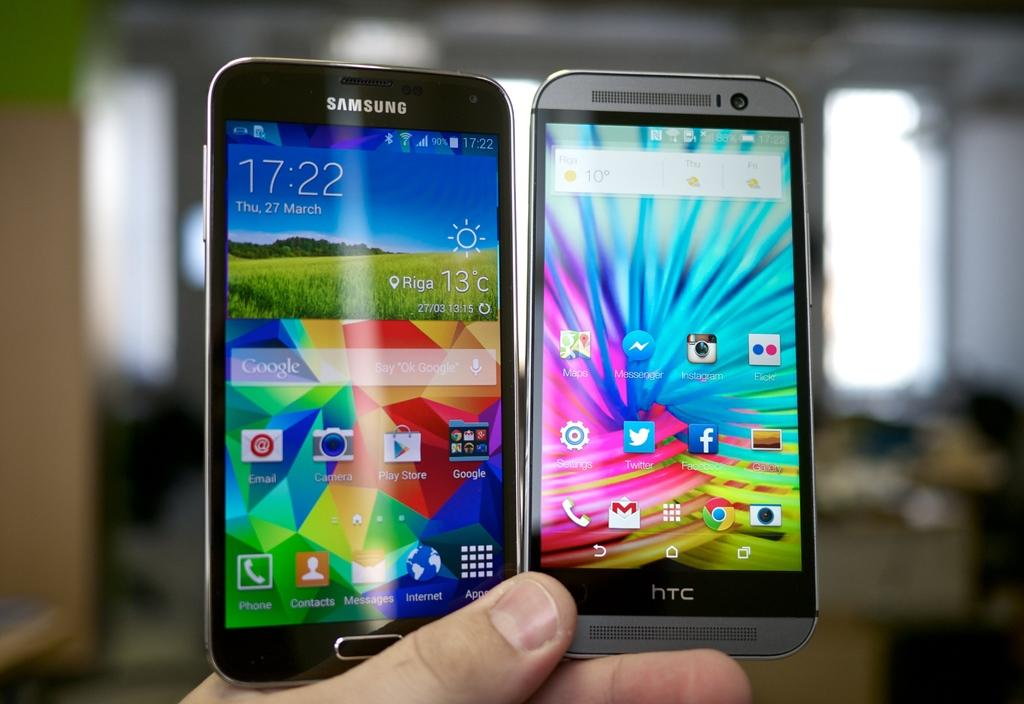<image>
Render a clear and concise summary of the photo. a black Samsung cell phone and silver HTC cell phone held in a hand 